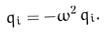Convert formula to latex. <formula><loc_0><loc_0><loc_500><loc_500>\ddot { q _ { i } } = - \omega ^ { 2 } \, q _ { i } .</formula> 